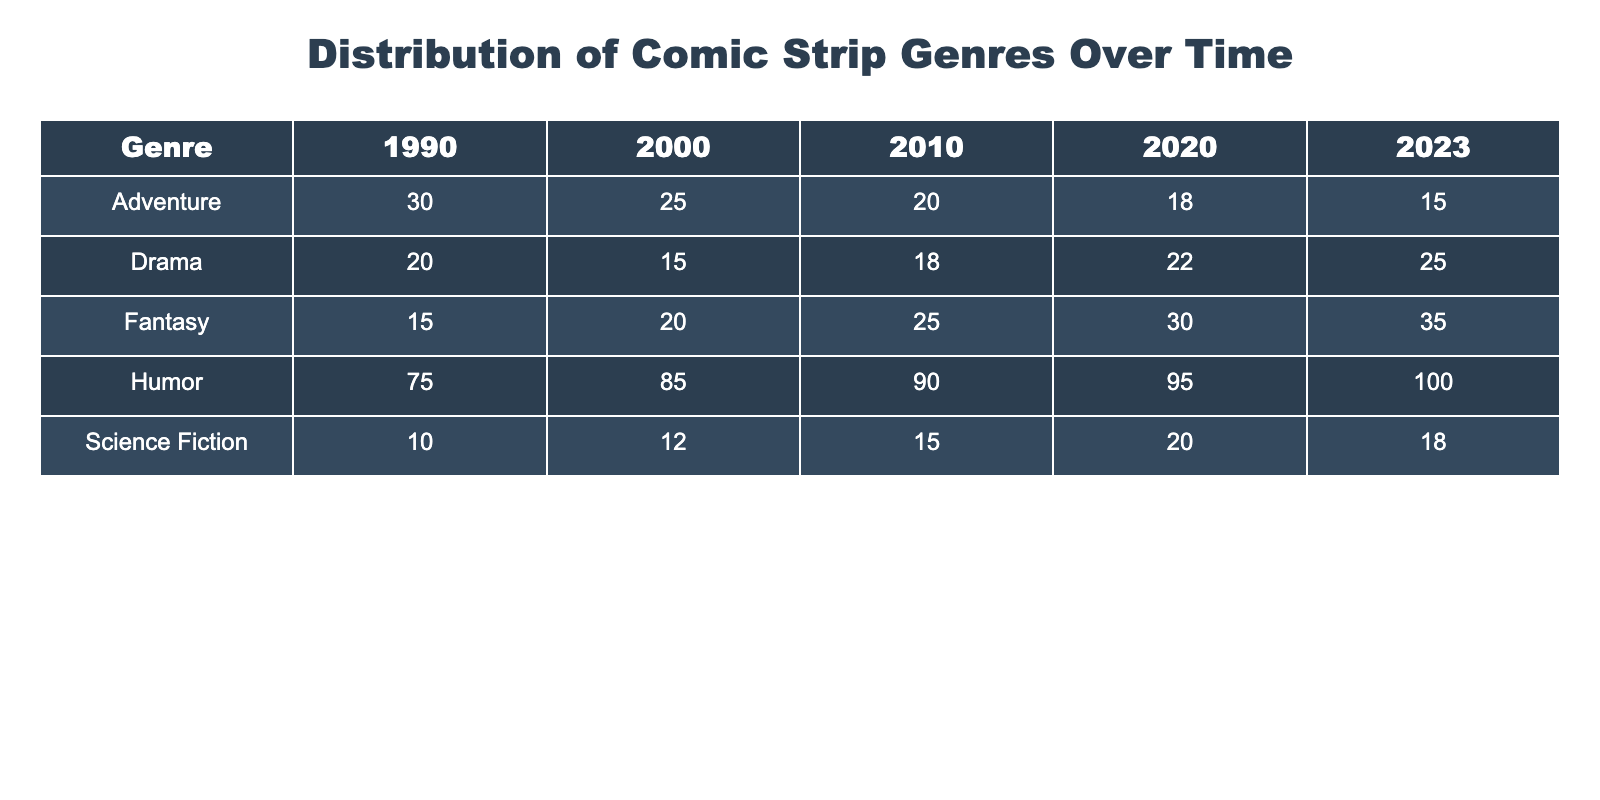What was the count of Adventure genre comics in 1990? In the table, we can find the count of the Adventure genre comics listed under the '1990' column. It shows a count of 30.
Answer: 30 Which genre had the highest count in 2023? Looking at the 2023 column, the Humor genre has the highest count at 100 compared to other genres.
Answer: Humor What is the total count of Fantasy comics across all years? To find the total count of Fantasy comics, we add the counts for each year: 15 (1990) + 20 (2000) + 25 (2010) + 30 (2020) + 35 (2023) = 125.
Answer: 125 How has the count of Humor genre comics changed from 1990 to 2023? The count of Humor genre comics in 1990 was 75, and in 2023 it is 100. The change is 100 - 75 = 25 more comics in 2023 compared to 1990.
Answer: Increased by 25 What is the difference in the count of Science Fiction comics between 1990 and 2020? The count of Science Fiction comics in 1990 was 10, and in 2020 it was 20. To find the difference, we subtract: 20 - 10 = 10.
Answer: 10 Is there a genre that consistently decreased in count every decade? Checking each genre across the years, the Adventure genre shows a decrease: 30 (1990), 25 (2000), 20 (2010), 18 (2020), and 15 (2023). Hence, it consistently decreased.
Answer: Yes Which year saw the highest overall count of comics across all genres? We sum the counts for each year: 1990 (150), 2000 (142), 2010 (168), 2020 (185), 2023 (188). The highest is 2023 with 188.
Answer: 2023 What was the average count of Drama comics from 1990 to 2023? The counts for Drama comics are: 20 (1990), 15 (2000), 18 (2010), 22 (2020), and 25 (2023). Summing these gives 100, and dividing by 5 gives an average of 20.
Answer: 20 How many more Humor comics were there in 2020 compared to Adventure comics in the same year? In 2020, the Humor count was 95 and the Adventure count was 18. We calculate the difference: 95 - 18 = 77.
Answer: 77 What trend can be observed in the counts of Sci-Fi comics from 1990 to 2023? The counts for Sci-Fi comics are: 10 (1990), 12 (2000), 15 (2010), 20 (2020), and 18 (2023). The trend shows an overall increase followed by a slight decrease from 2020 to 2023.
Answer: Increase then slight decrease 